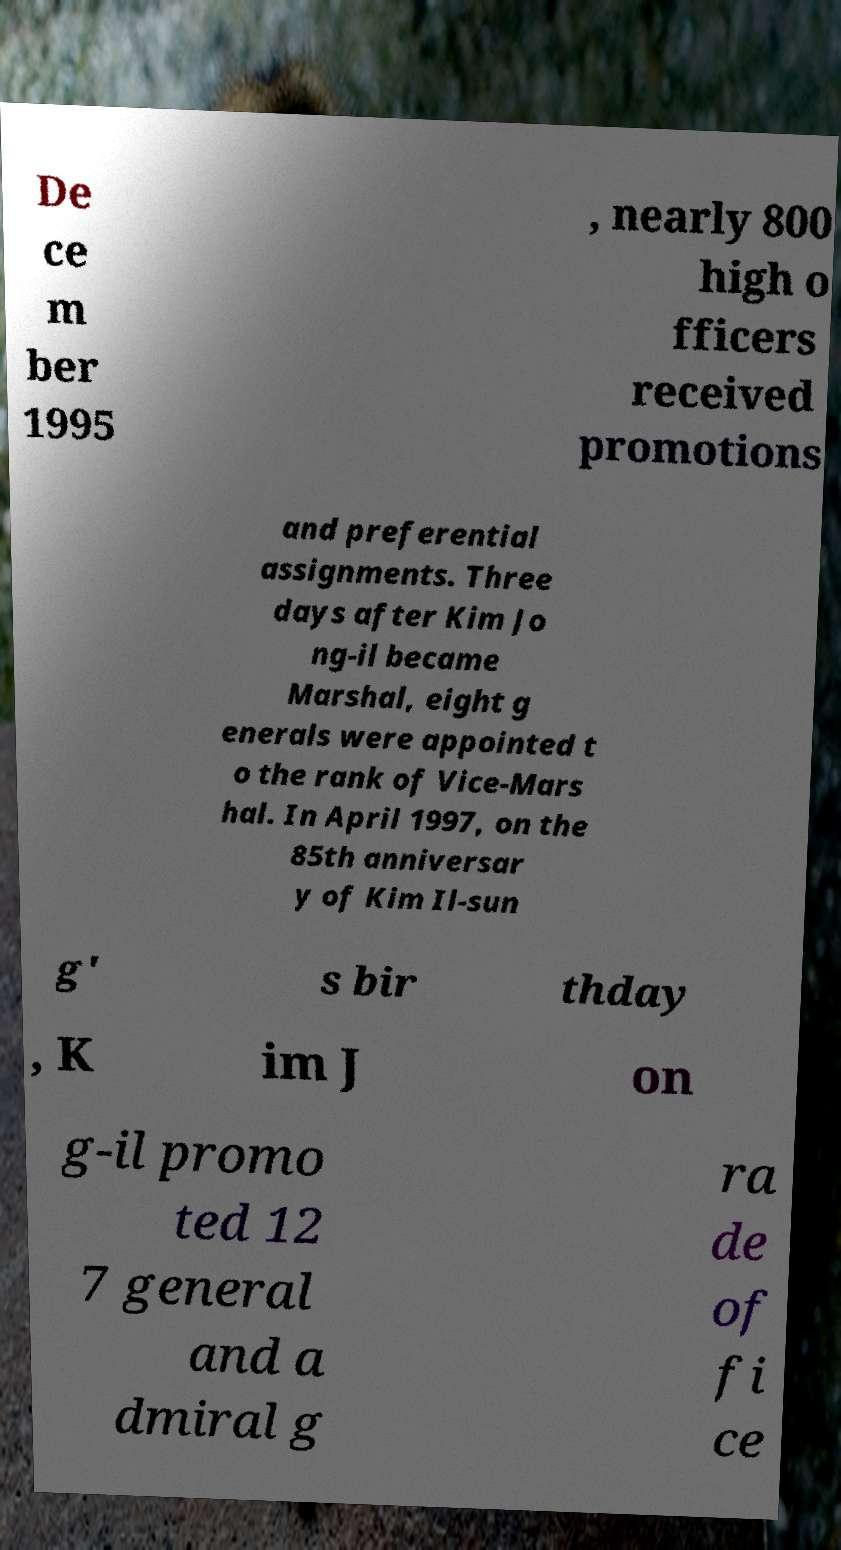I need the written content from this picture converted into text. Can you do that? De ce m ber 1995 , nearly 800 high o fficers received promotions and preferential assignments. Three days after Kim Jo ng-il became Marshal, eight g enerals were appointed t o the rank of Vice-Mars hal. In April 1997, on the 85th anniversar y of Kim Il-sun g' s bir thday , K im J on g-il promo ted 12 7 general and a dmiral g ra de of fi ce 